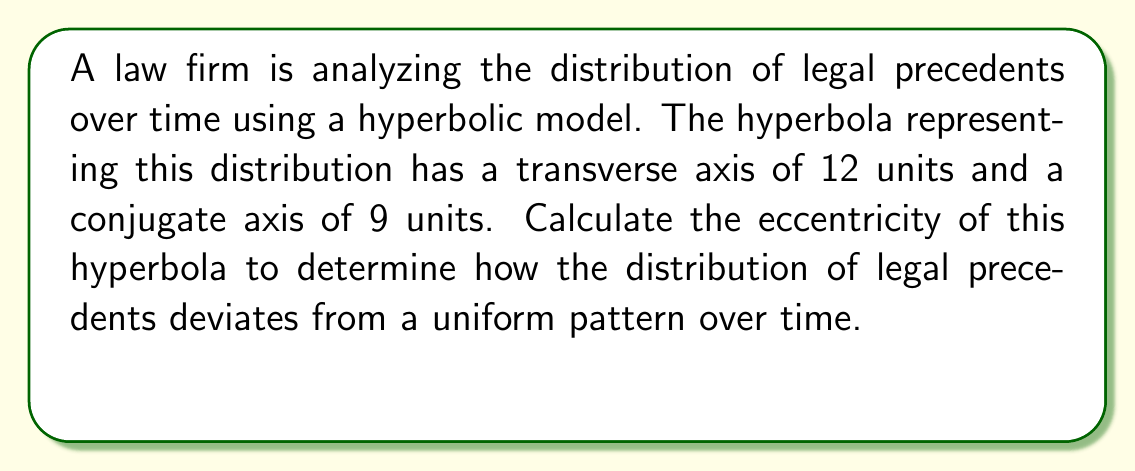Can you answer this question? To calculate the eccentricity of a hyperbola, we need to use the formula:

$$ e = \frac{c}{a} $$

Where:
- $e$ is the eccentricity
- $c$ is the distance from the center to a focus
- $a$ is half the length of the transverse axis

We are given:
- Transverse axis = 12 units, so $a = 6$
- Conjugate axis = 9 units, so $b = 4.5$

Step 1: Calculate $c$ using the Pythagorean theorem for hyperbolas:
$$ c^2 = a^2 + b^2 $$
$$ c^2 = 6^2 + 4.5^2 $$
$$ c^2 = 36 + 20.25 = 56.25 $$
$$ c = \sqrt{56.25} = 7.5 $$

Step 2: Calculate the eccentricity using the formula:
$$ e = \frac{c}{a} = \frac{7.5}{6} = 1.25 $$

The eccentricity of 1.25 indicates that the distribution of legal precedents deviates significantly from a uniform pattern over time. An eccentricity greater than 1 is characteristic of hyperbolas, with values closer to 1 indicating a less pronounced curve and values much greater than 1 indicating a more pronounced curve.
Answer: $e = 1.25$ 